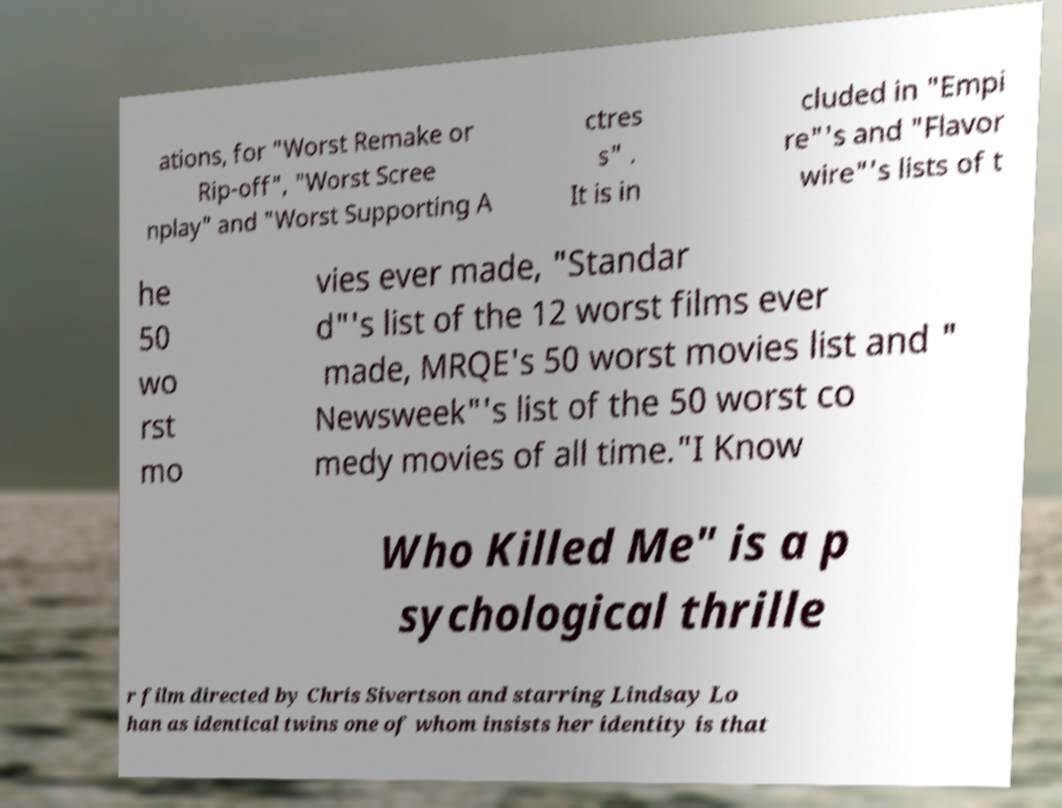Please identify and transcribe the text found in this image. ations, for "Worst Remake or Rip-off", "Worst Scree nplay" and "Worst Supporting A ctres s" . It is in cluded in "Empi re"'s and "Flavor wire"'s lists of t he 50 wo rst mo vies ever made, "Standar d"'s list of the 12 worst films ever made, MRQE's 50 worst movies list and " Newsweek"'s list of the 50 worst co medy movies of all time."I Know Who Killed Me" is a p sychological thrille r film directed by Chris Sivertson and starring Lindsay Lo han as identical twins one of whom insists her identity is that 